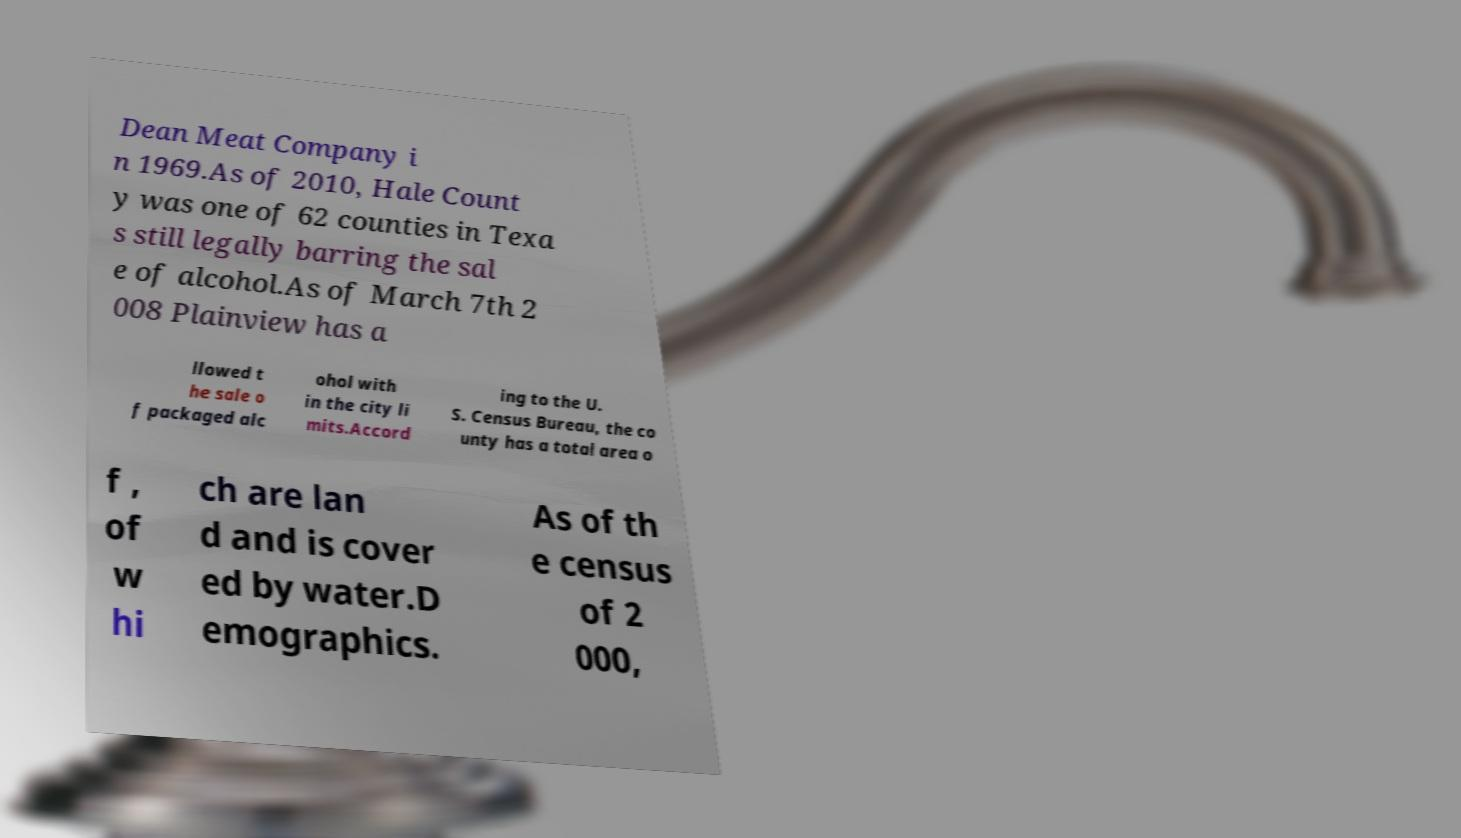Can you read and provide the text displayed in the image?This photo seems to have some interesting text. Can you extract and type it out for me? Dean Meat Company i n 1969.As of 2010, Hale Count y was one of 62 counties in Texa s still legally barring the sal e of alcohol.As of March 7th 2 008 Plainview has a llowed t he sale o f packaged alc ohol with in the city li mits.Accord ing to the U. S. Census Bureau, the co unty has a total area o f , of w hi ch are lan d and is cover ed by water.D emographics. As of th e census of 2 000, 